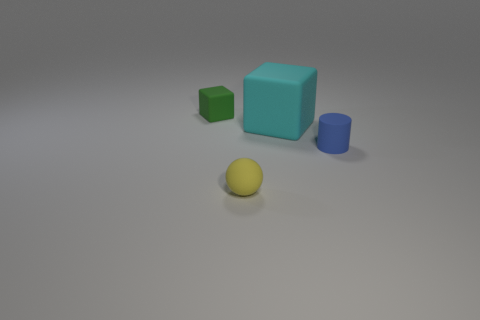There is a yellow ball that is made of the same material as the small green block; what is its size?
Keep it short and to the point. Small. Is the size of the ball the same as the cube that is to the right of the rubber ball?
Keep it short and to the point. No. Is the cyan rubber thing the same shape as the green thing?
Keep it short and to the point. Yes. There is a rubber thing that is in front of the big cyan object and on the left side of the blue cylinder; how big is it?
Ensure brevity in your answer.  Small. What shape is the tiny green thing that is the same material as the blue thing?
Keep it short and to the point. Cube. There is a big thing; is its shape the same as the small matte thing behind the big matte thing?
Give a very brief answer. Yes. The small thing that is in front of the small object on the right side of the yellow rubber thing is made of what material?
Give a very brief answer. Rubber. Are there an equal number of cubes right of the small sphere and big cyan things?
Your response must be concise. Yes. What number of things are in front of the large cyan cube and to the right of the yellow thing?
Offer a terse response. 1. What number of other objects are there of the same shape as the green thing?
Ensure brevity in your answer.  1. 